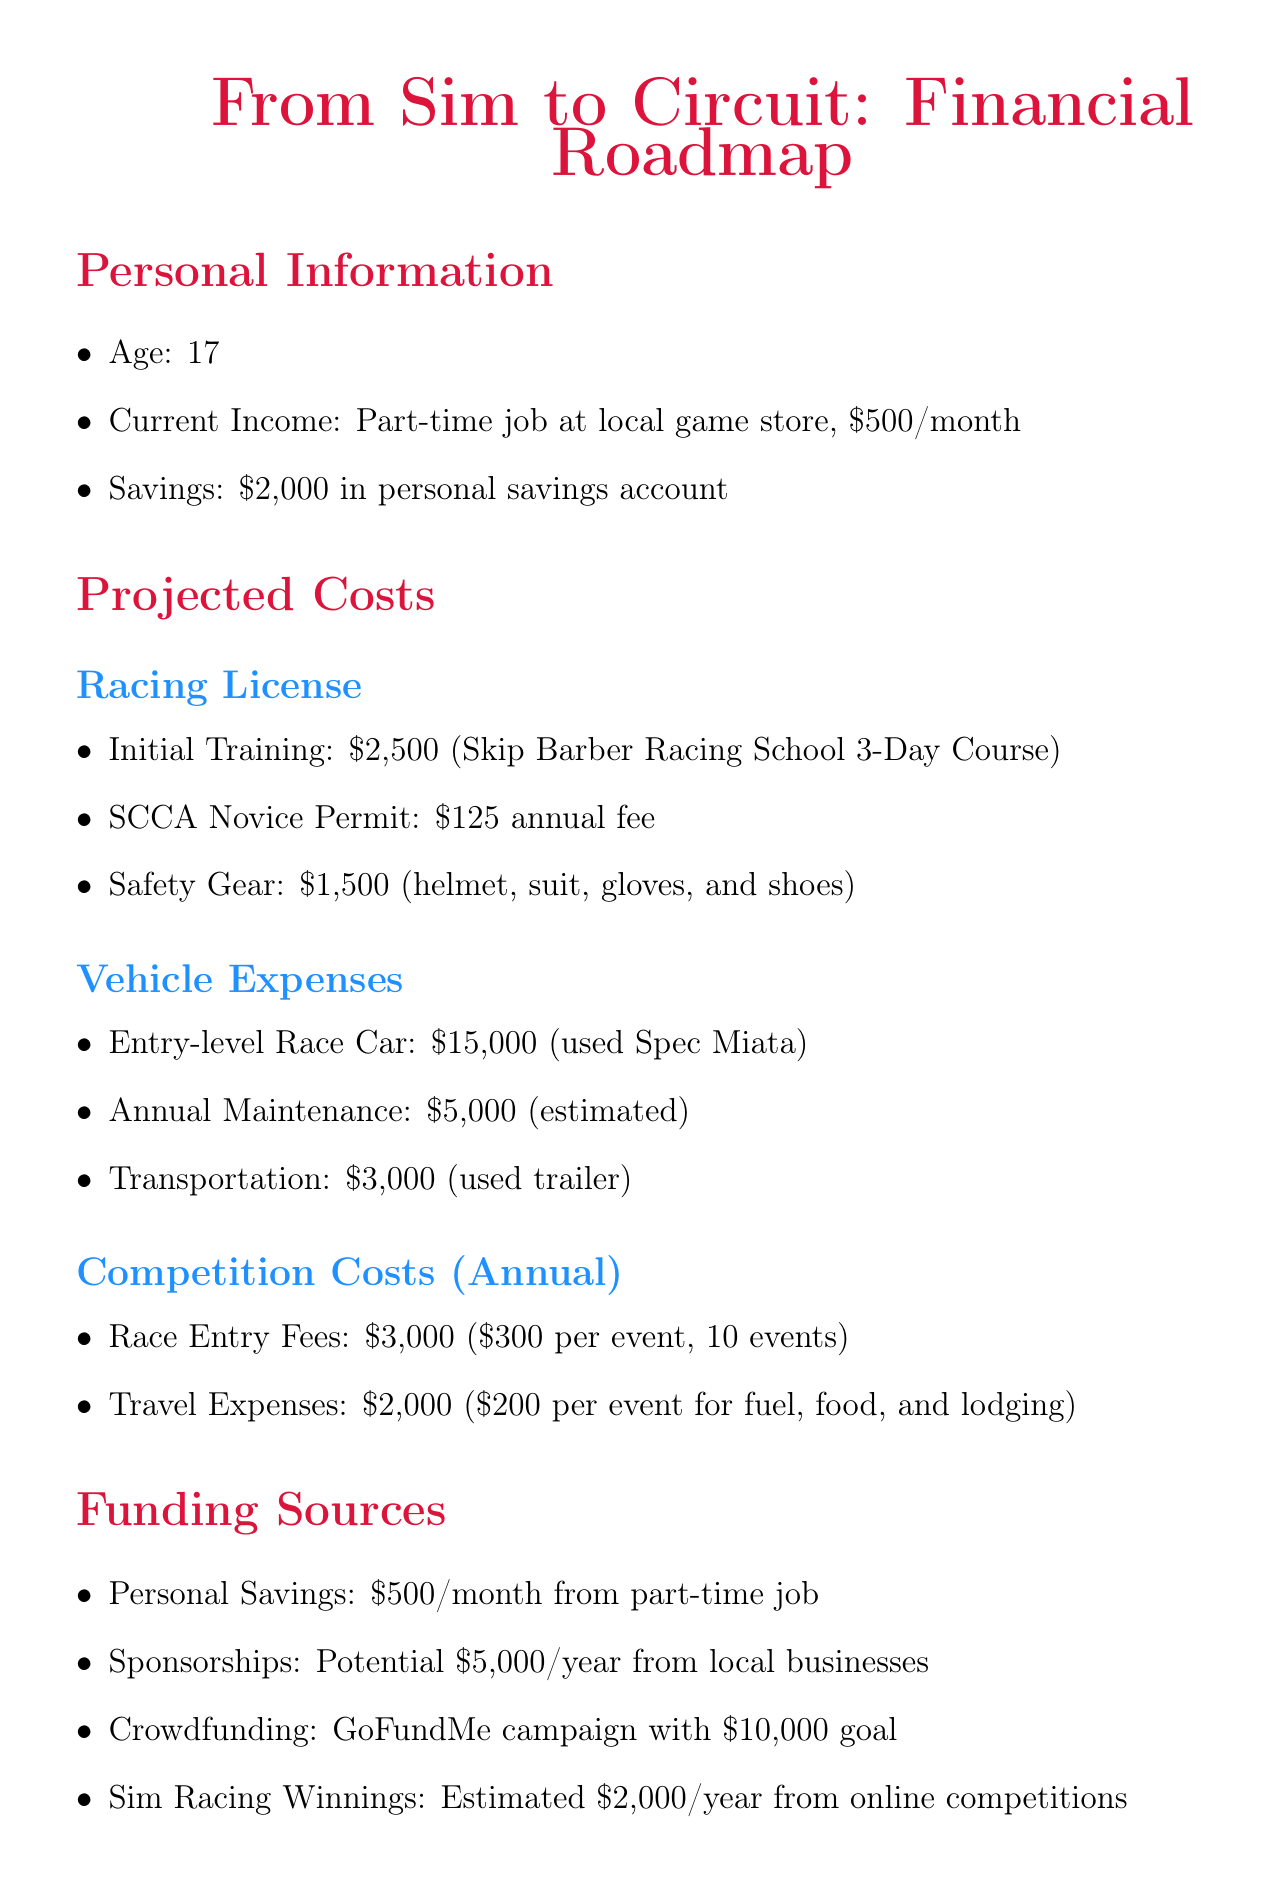what is the age of the individual? The individual's age is stated in the personal information section of the document.
Answer: 17 how much is the initial training cost for the racing license? The initial training cost for the racing license is detailed in the racing license costs section.
Answer: $2,500 what is the estimated annual budget for a full season campaign? The estimated annual budget is provided in the long-term goals section of the document.
Answer: $250,000 how much can be allocated from personal savings each month? The monthly amount that can be allocated from personal savings is specified under funding sources.
Answer: $500/month what is the total estimated cost for race entry fees in a year? The total estimated cost is derived from the number of events and the fee per event specified in the competition costs section.
Answer: $3,000 how much funding is expected from sponsorships annually? The potential amount that can be obtained from sponsorships is found in the funding sources section.
Answer: $5,000/year what is the goal for year 2 in career progression? The goal for year 2 is indicated in the career progression table of the document.
Answer: Move to national level competitions what is the goal amount for the GoFundMe campaign? The goal amount for the crowdfunding effort is outlined in the funding sources section.
Answer: $10,000 